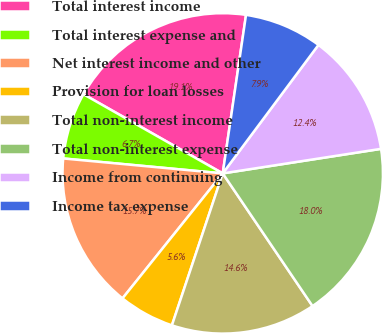Convert chart to OTSL. <chart><loc_0><loc_0><loc_500><loc_500><pie_chart><fcel>Total interest income<fcel>Total interest expense and<fcel>Net interest income and other<fcel>Provision for loan losses<fcel>Total non-interest income<fcel>Total non-interest expense<fcel>Income from continuing<fcel>Income tax expense<nl><fcel>19.1%<fcel>6.74%<fcel>15.73%<fcel>5.62%<fcel>14.61%<fcel>17.98%<fcel>12.36%<fcel>7.87%<nl></chart> 